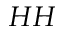Convert formula to latex. <formula><loc_0><loc_0><loc_500><loc_500>H H</formula> 